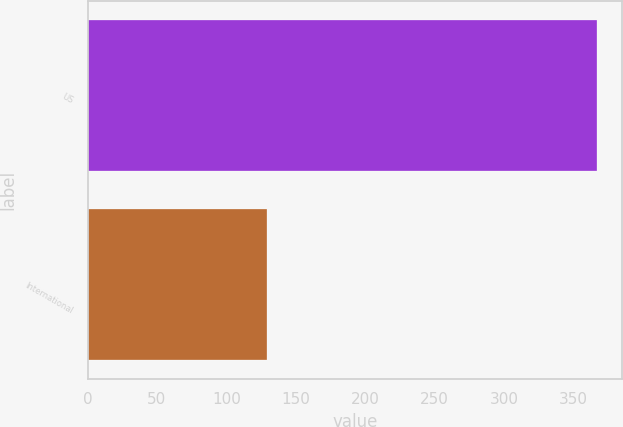Convert chart to OTSL. <chart><loc_0><loc_0><loc_500><loc_500><bar_chart><fcel>US<fcel>International<nl><fcel>367<fcel>129<nl></chart> 